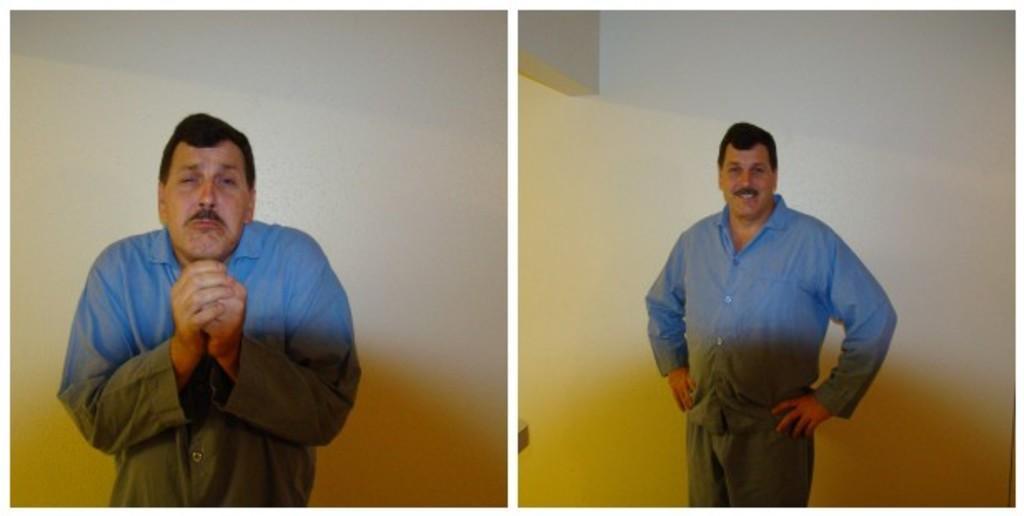Could you give a brief overview of what you see in this image? In this image I can see replica of two pictures, on which on the right side there is a person standing might be in front of the wall, on right side there is a person standing might be in front of the wall, he is smiling. 